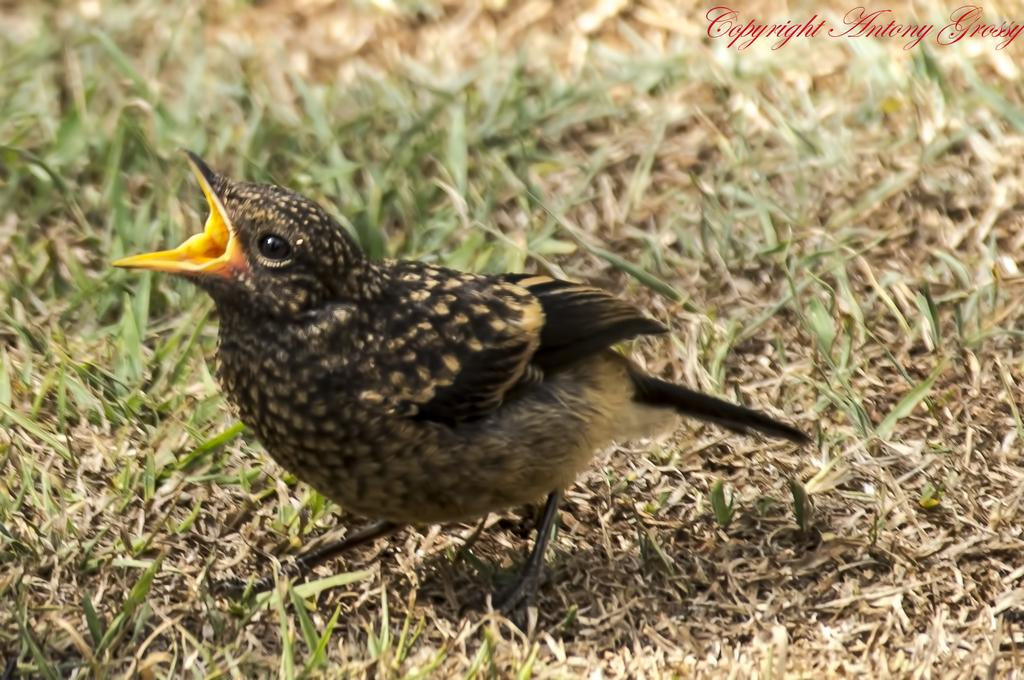What type of animal is in the image? There is a bird in the image. Where is the bird located? The bird is on the grass. Can you describe any additional features of the image? There is a watermark in the top right corner of the image. What year is the bird in jail in the image? There is no indication of a bird being in jail or any specific year in the image. 